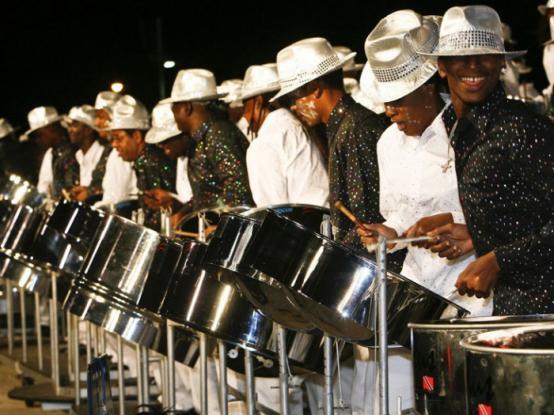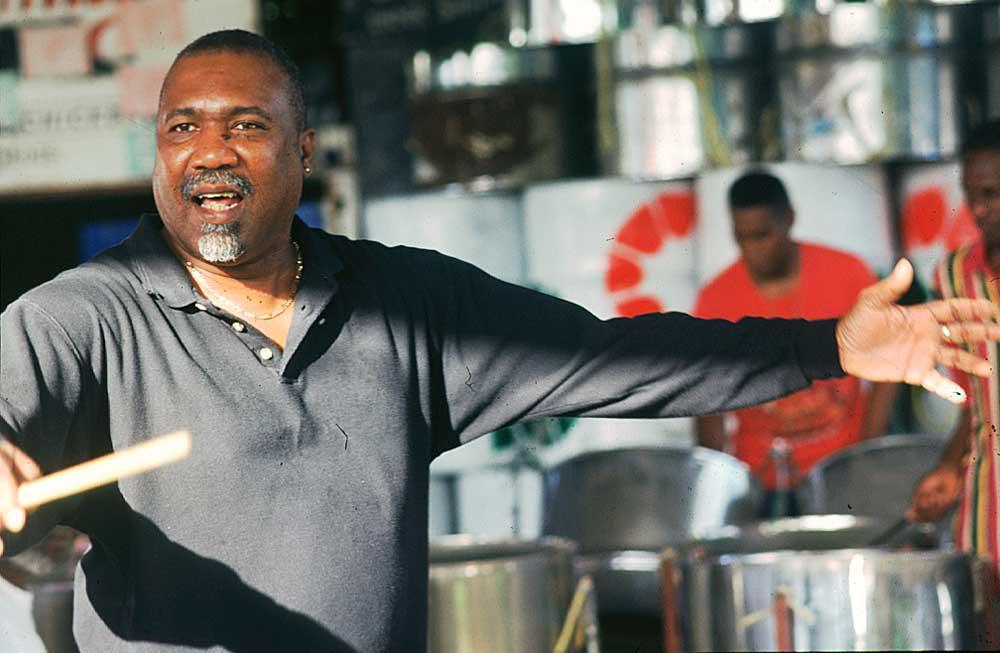The first image is the image on the left, the second image is the image on the right. Evaluate the accuracy of this statement regarding the images: "The left image shows musicians standing behind no more than four steel drums, and exactly one musician is wearing a fedora hat.". Is it true? Answer yes or no. No. The first image is the image on the left, the second image is the image on the right. Examine the images to the left and right. Is the description "There is at least one person wearing a hat." accurate? Answer yes or no. Yes. 